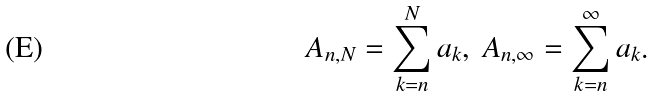<formula> <loc_0><loc_0><loc_500><loc_500>A _ { n , N } = \sum ^ { N } _ { k = n } a _ { k } , \ A _ { n , \infty } = \sum ^ { \infty } _ { k = n } a _ { k } .</formula> 